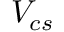Convert formula to latex. <formula><loc_0><loc_0><loc_500><loc_500>V _ { c s }</formula> 